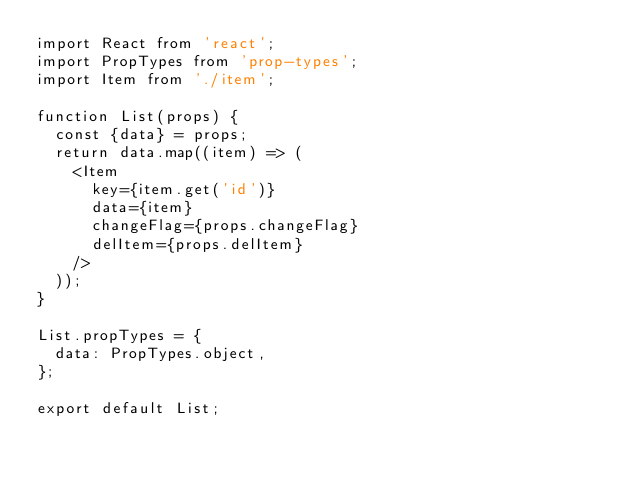Convert code to text. <code><loc_0><loc_0><loc_500><loc_500><_JavaScript_>import React from 'react';
import PropTypes from 'prop-types';
import Item from './item';

function List(props) {
  const {data} = props;
  return data.map((item) => (
    <Item
      key={item.get('id')}
      data={item}
      changeFlag={props.changeFlag}
      delItem={props.delItem}
    />
  ));
}

List.propTypes = {
  data: PropTypes.object,
};

export default List;
</code> 